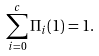Convert formula to latex. <formula><loc_0><loc_0><loc_500><loc_500>\sum _ { i = 0 } ^ { c } \Pi _ { i } ( 1 ) = 1 .</formula> 